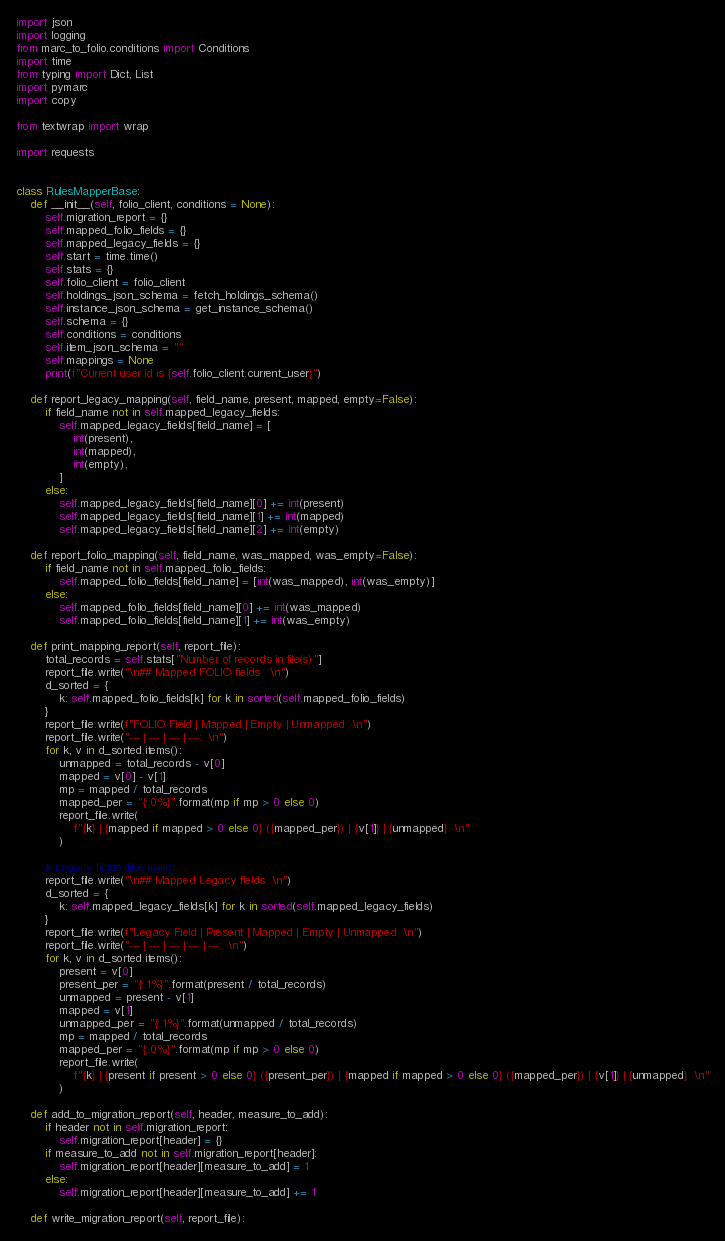Convert code to text. <code><loc_0><loc_0><loc_500><loc_500><_Python_>import json
import logging
from marc_to_folio.conditions import Conditions
import time
from typing import Dict, List
import pymarc
import copy

from textwrap import wrap

import requests


class RulesMapperBase:
    def __init__(self, folio_client, conditions = None):
        self.migration_report = {}
        self.mapped_folio_fields = {}
        self.mapped_legacy_fields = {}
        self.start = time.time()
        self.stats = {}
        self.folio_client = folio_client
        self.holdings_json_schema = fetch_holdings_schema()
        self.instance_json_schema = get_instance_schema()
        self.schema = {}
        self.conditions = conditions
        self.item_json_schema = ""
        self.mappings = None
        print(f"Current user id is {self.folio_client.current_user}")

    def report_legacy_mapping(self, field_name, present, mapped, empty=False):
        if field_name not in self.mapped_legacy_fields:
            self.mapped_legacy_fields[field_name] = [
                int(present),
                int(mapped),
                int(empty),
            ]
        else:
            self.mapped_legacy_fields[field_name][0] += int(present)
            self.mapped_legacy_fields[field_name][1] += int(mapped)
            self.mapped_legacy_fields[field_name][2] += int(empty)

    def report_folio_mapping(self, field_name, was_mapped, was_empty=False):
        if field_name not in self.mapped_folio_fields:
            self.mapped_folio_fields[field_name] = [int(was_mapped), int(was_empty)]
        else:
            self.mapped_folio_fields[field_name][0] += int(was_mapped)
            self.mapped_folio_fields[field_name][1] += int(was_empty)

    def print_mapping_report(self, report_file):
        total_records = self.stats["Number of records in file(s)"]
        report_file.write("\n## Mapped FOLIO fields   \n")
        d_sorted = {
            k: self.mapped_folio_fields[k] for k in sorted(self.mapped_folio_fields)
        }
        report_file.write(f"FOLIO Field | Mapped | Empty | Unmapped  \n")
        report_file.write("--- | --- | --- | ---:  \n")
        for k, v in d_sorted.items():
            unmapped = total_records - v[0]
            mapped = v[0] - v[1]
            mp = mapped / total_records
            mapped_per = "{:.0%}".format(mp if mp > 0 else 0)
            report_file.write(
                f"{k} | {mapped if mapped > 0 else 0} ({mapped_per}) | {v[1]} | {unmapped}  \n"
            )

        # Legacy fields (like marc)
        report_file.write("\n## Mapped Legacy fields  \n")
        d_sorted = {
            k: self.mapped_legacy_fields[k] for k in sorted(self.mapped_legacy_fields)
        }
        report_file.write(f"Legacy Field | Present | Mapped | Empty | Unmapped  \n")
        report_file.write("--- | --- | --- | --- | ---:  \n")
        for k, v in d_sorted.items():
            present = v[0]
            present_per = "{:.1%}".format(present / total_records)
            unmapped = present - v[1]
            mapped = v[1]
            unmapped_per = "{:.1%}".format(unmapped / total_records)
            mp = mapped / total_records
            mapped_per = "{:.0%}".format(mp if mp > 0 else 0)
            report_file.write(
                f"{k} | {present if present > 0 else 0} ({present_per}) | {mapped if mapped > 0 else 0} ({mapped_per}) | {v[1]} | {unmapped}  \n"
            )

    def add_to_migration_report(self, header, measure_to_add):
        if header not in self.migration_report:
            self.migration_report[header] = {}
        if measure_to_add not in self.migration_report[header]:
            self.migration_report[header][measure_to_add] = 1
        else:
            self.migration_report[header][measure_to_add] += 1

    def write_migration_report(self, report_file):
</code> 